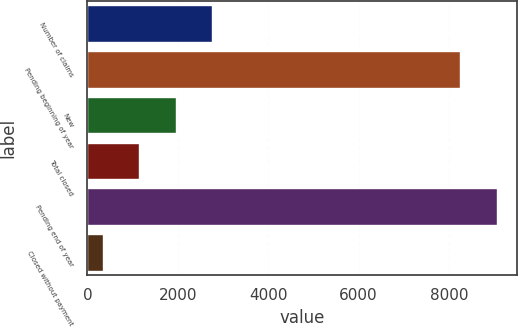<chart> <loc_0><loc_0><loc_500><loc_500><bar_chart><fcel>Number of claims<fcel>Pending beginning of year<fcel>New<fcel>Total closed<fcel>Pending end of year<fcel>Closed without payment<nl><fcel>2761.5<fcel>8252<fcel>1953<fcel>1144.5<fcel>9060.5<fcel>336<nl></chart> 